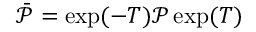<formula> <loc_0><loc_0><loc_500><loc_500>\bar { \mathcal { P } } = \exp ( - T ) \mathcal { P } \exp ( T )</formula> 